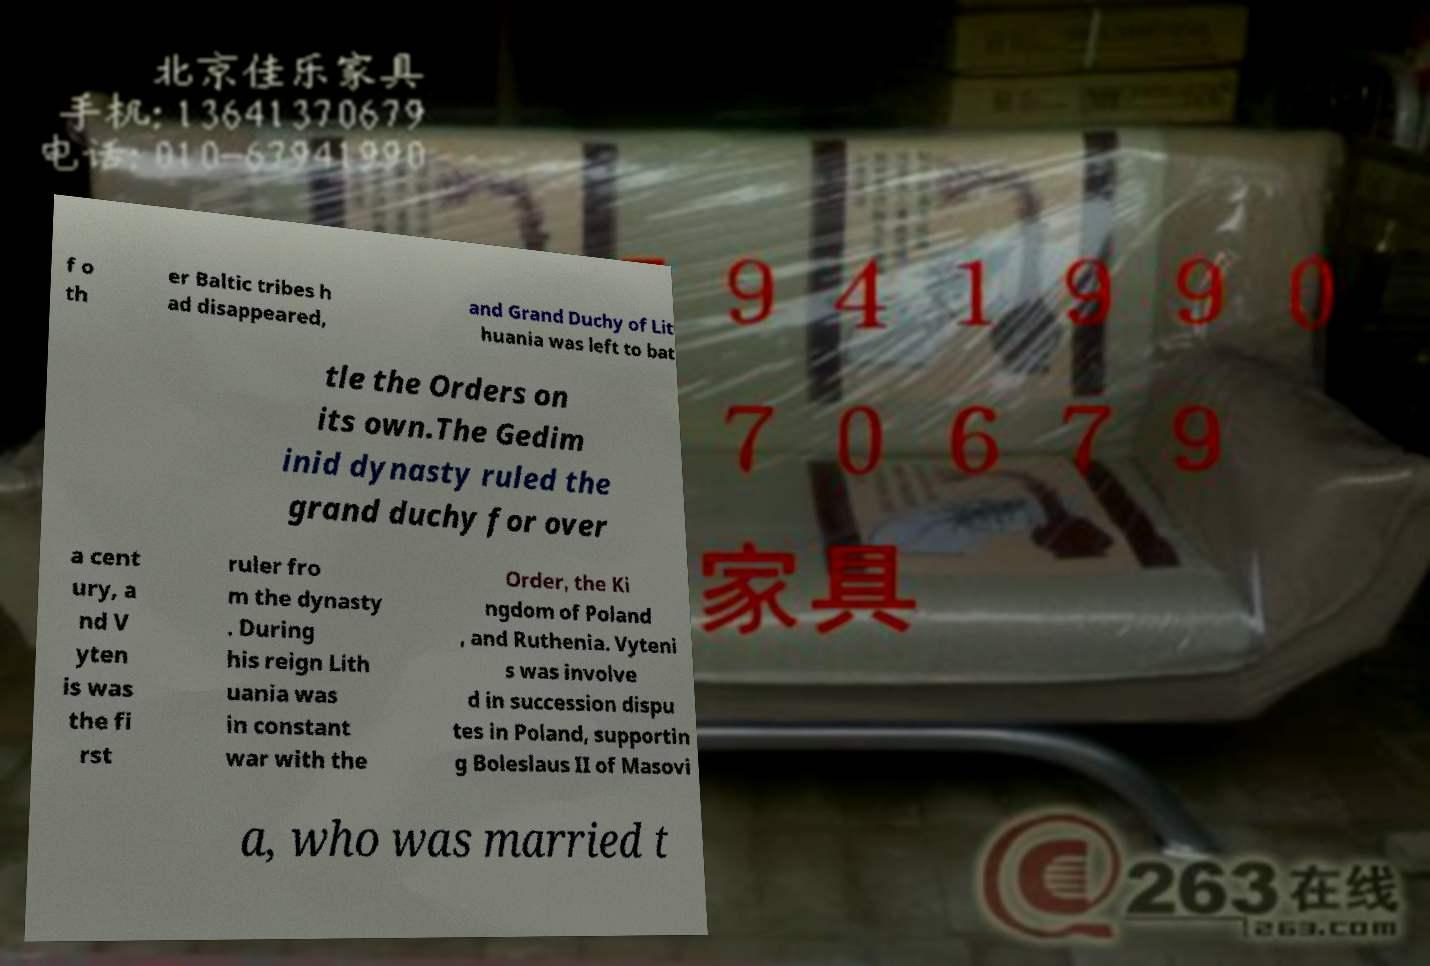Could you extract and type out the text from this image? f o th er Baltic tribes h ad disappeared, and Grand Duchy of Lit huania was left to bat tle the Orders on its own.The Gedim inid dynasty ruled the grand duchy for over a cent ury, a nd V yten is was the fi rst ruler fro m the dynasty . During his reign Lith uania was in constant war with the Order, the Ki ngdom of Poland , and Ruthenia. Vyteni s was involve d in succession dispu tes in Poland, supportin g Boleslaus II of Masovi a, who was married t 